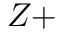Convert formula to latex. <formula><loc_0><loc_0><loc_500><loc_500>Z +</formula> 